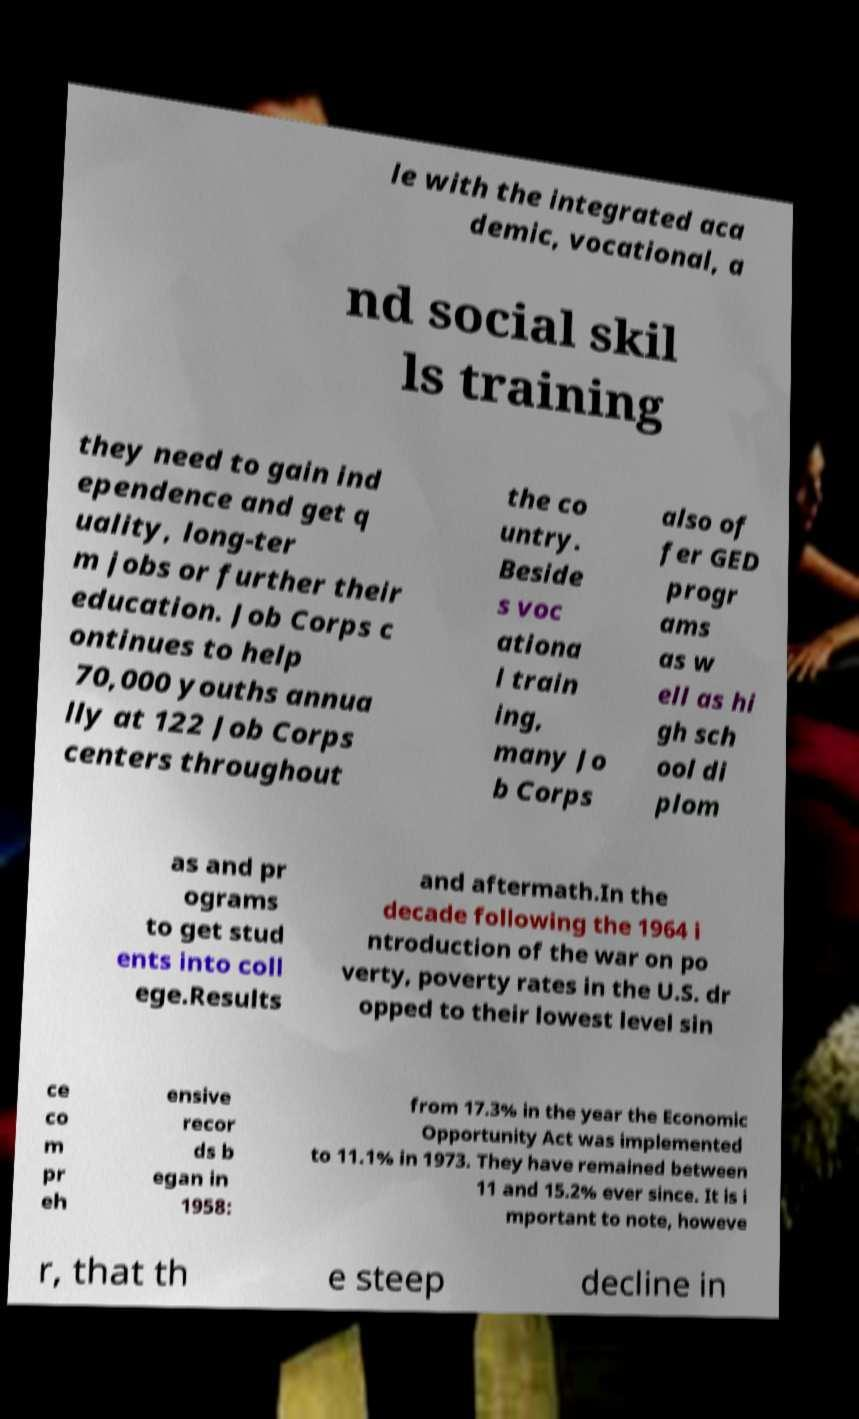Could you extract and type out the text from this image? le with the integrated aca demic, vocational, a nd social skil ls training they need to gain ind ependence and get q uality, long-ter m jobs or further their education. Job Corps c ontinues to help 70,000 youths annua lly at 122 Job Corps centers throughout the co untry. Beside s voc ationa l train ing, many Jo b Corps also of fer GED progr ams as w ell as hi gh sch ool di plom as and pr ograms to get stud ents into coll ege.Results and aftermath.In the decade following the 1964 i ntroduction of the war on po verty, poverty rates in the U.S. dr opped to their lowest level sin ce co m pr eh ensive recor ds b egan in 1958: from 17.3% in the year the Economic Opportunity Act was implemented to 11.1% in 1973. They have remained between 11 and 15.2% ever since. It is i mportant to note, howeve r, that th e steep decline in 